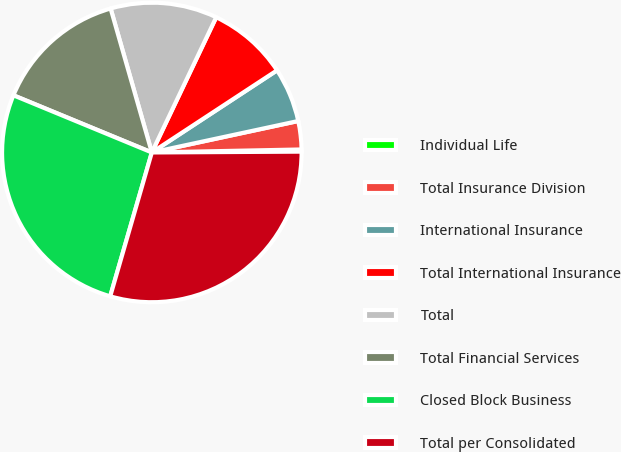Convert chart. <chart><loc_0><loc_0><loc_500><loc_500><pie_chart><fcel>Individual Life<fcel>Total Insurance Division<fcel>International Insurance<fcel>Total International Insurance<fcel>Total<fcel>Total Financial Services<fcel>Closed Block Business<fcel>Total per Consolidated<nl><fcel>0.23%<fcel>3.05%<fcel>5.87%<fcel>8.69%<fcel>11.51%<fcel>14.33%<fcel>26.75%<fcel>29.57%<nl></chart> 